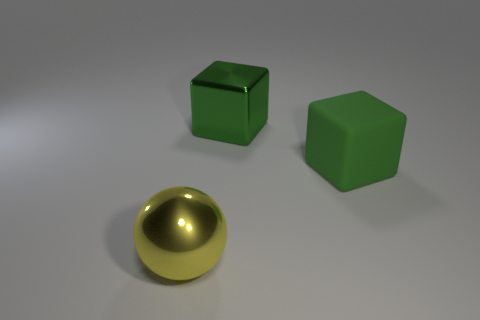How many large green objects are on the left side of the big cube in front of the shiny thing behind the big shiny ball?
Your answer should be compact. 1. Is the number of big yellow objects behind the big green metallic object greater than the number of metal balls behind the green rubber block?
Your answer should be very brief. No. What number of yellow metallic objects have the same shape as the green metallic thing?
Offer a very short reply. 0. How many objects are either objects that are in front of the large green rubber cube or objects behind the yellow metallic sphere?
Your answer should be compact. 3. The green thing to the left of the block in front of the big metallic object that is on the right side of the yellow metallic ball is made of what material?
Keep it short and to the point. Metal. There is a big shiny thing in front of the large matte object; does it have the same color as the big rubber block?
Provide a short and direct response. No. There is a thing that is both behind the big yellow shiny thing and in front of the big metallic cube; what is it made of?
Your answer should be compact. Rubber. Is there a blue cylinder that has the same size as the yellow metal ball?
Provide a succinct answer. No. How many yellow metal things are there?
Your answer should be very brief. 1. How many blocks are behind the green matte cube?
Offer a very short reply. 1. 